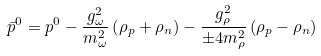<formula> <loc_0><loc_0><loc_500><loc_500>\bar { p } ^ { 0 } = p ^ { 0 } - \frac { g ^ { 2 } _ { \omega } } { m ^ { 2 } _ { \omega } } \left ( \rho _ { p } + \rho _ { n } \right ) - \frac { g ^ { 2 } _ { \rho } } { \pm 4 m ^ { 2 } _ { \rho } } \left ( \rho _ { p } - \rho _ { n } \right )</formula> 